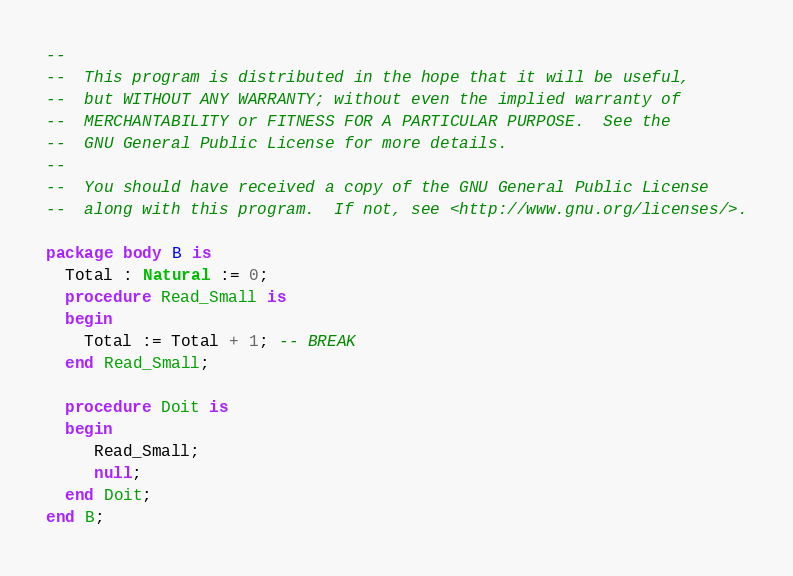Convert code to text. <code><loc_0><loc_0><loc_500><loc_500><_Ada_>--
--  This program is distributed in the hope that it will be useful,
--  but WITHOUT ANY WARRANTY; without even the implied warranty of
--  MERCHANTABILITY or FITNESS FOR A PARTICULAR PURPOSE.  See the
--  GNU General Public License for more details.
--
--  You should have received a copy of the GNU General Public License
--  along with this program.  If not, see <http://www.gnu.org/licenses/>.

package body B is
  Total : Natural := 0;
  procedure Read_Small is
  begin
    Total := Total + 1; -- BREAK
  end Read_Small;

  procedure Doit is
  begin
     Read_Small;
     null;
  end Doit;
end B;
</code> 